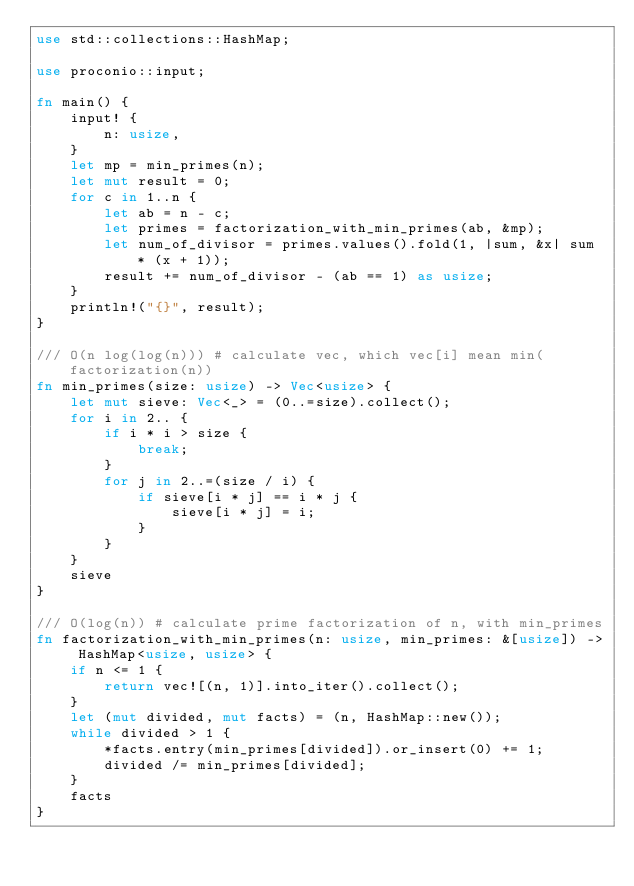Convert code to text. <code><loc_0><loc_0><loc_500><loc_500><_Rust_>use std::collections::HashMap;

use proconio::input;

fn main() {
    input! {
        n: usize,
    }
    let mp = min_primes(n);
    let mut result = 0;
    for c in 1..n {
        let ab = n - c;
        let primes = factorization_with_min_primes(ab, &mp);
        let num_of_divisor = primes.values().fold(1, |sum, &x| sum * (x + 1));
        result += num_of_divisor - (ab == 1) as usize;
    }
    println!("{}", result);
}

/// O(n log(log(n))) # calculate vec, which vec[i] mean min(factorization(n))
fn min_primes(size: usize) -> Vec<usize> {
    let mut sieve: Vec<_> = (0..=size).collect();
    for i in 2.. {
        if i * i > size {
            break;
        }
        for j in 2..=(size / i) {
            if sieve[i * j] == i * j {
                sieve[i * j] = i;
            }
        }
    }
    sieve
}

/// O(log(n)) # calculate prime factorization of n, with min_primes
fn factorization_with_min_primes(n: usize, min_primes: &[usize]) -> HashMap<usize, usize> {
    if n <= 1 {
        return vec![(n, 1)].into_iter().collect();
    }
    let (mut divided, mut facts) = (n, HashMap::new());
    while divided > 1 {
        *facts.entry(min_primes[divided]).or_insert(0) += 1;
        divided /= min_primes[divided];
    }
    facts
}
</code> 